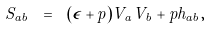Convert formula to latex. <formula><loc_0><loc_0><loc_500><loc_500>S _ { a b } \ = \ ( \epsilon + p ) V _ { a } V _ { b } + p h _ { a b } ,</formula> 